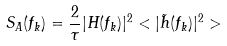Convert formula to latex. <formula><loc_0><loc_0><loc_500><loc_500>S _ { A } ( f _ { k } ) = \frac { 2 } { \tau } | H ( f _ { k } ) | ^ { 2 } < | \tilde { h } ( f _ { k } ) | ^ { 2 } ></formula> 